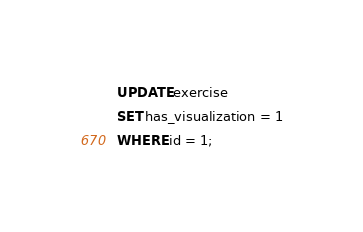Convert code to text. <code><loc_0><loc_0><loc_500><loc_500><_SQL_>UPDATE exercise
SET has_visualization = 1
WHERE id = 1;</code> 